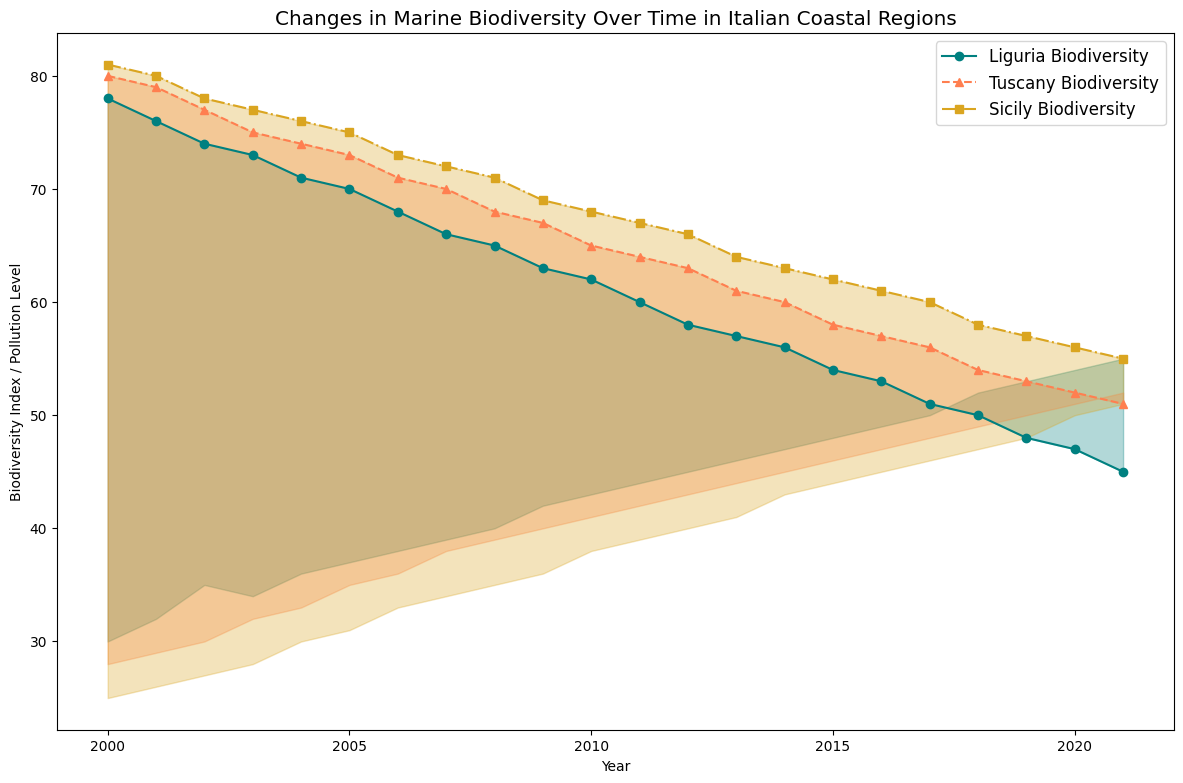In which region did the Biodiversity Index show the greatest decline from 2000 to 2021? Looking at the three regions (Liguria, Tuscany, and Sicily) on the plot, Liguria's Biodiversity Index dropped from around 78 to 45, Tuscany's from 80 to 51, and Sicily's from 81 to 55. Liguria experienced the greatest decline.
Answer: Liguria How does the pollution level change over time compare between Tuscany and Sicily from 2000 to 2021? Observing the plot, both Tuscany and Sicily show an upward trend in pollution levels from 2000 to 2021 but at different rates. Initially, Tuscany's pollution starts at 28 and ends at 52, whereas Sicily's pollution starts at 25 and ends at 51. Tuscany shows a slightly steeper increase in pollution levels over time.
Answer: Tuscany shows a slightly steeper increase Describe the visual difference in the area filled between the Biodiversity Index and Pollution Level for Liguria compared to Sicily. Liguria's area between the lines has a more pronounced downward slope towards the right, showing both rising pollution and a more steeply declining Biodiversity Index. Sicily shows a similar trend but to a lesser extent, with a smaller area between the lines suggesting a slower impact on biodiversity.
Answer: Liguria has a more pronounced decline Which region had the highest level of biodiversity in the year 2000 according to the plot? Looking at the starting points of the Biodiversity Index lines for the year 2000, Sicily starts at 81, Tuscany at 80, and Liguria at 78. Thus, Sicily had the highest biodiversity in 2000.
Answer: Sicily From which year does Liguria's Biodiversity Index drop below 60? Referring to the plot, Liguria's Biodiversity Index drops below 60 right after the year 2011, where it is shown at 60. So, it continues below 60 from 2012 onwards.
Answer: 2012 Between Tuscany and Liguria, which region had a higher pollution level in 2010? Examining the pollution levels plotted, Tuscany has a pollution level of 41 in 2010 while Liguria's pollution level is 43 in the same year. Therefore, Liguria had a higher pollution level in 2010.
Answer: Liguria By observing the area between the Biodiversity Index and Pollution Levels, which region appears to suffer the least impact of pollution on biodiversity over the years? The region with the smallest area between the Biodiversity Index and Pollution Levels would indicate a less severe impact. Sicily's area between the lines is narrower compared to Liguria and Tuscany, suggesting Sicily suffered the least relative impact over the years.
Answer: Sicily Approximately when did Tuscany's Biodiversity Index first fall below 70? Observing the line for Tuscany, the Biodiversity Index crosses below 70 around the year 2006.
Answer: Around 2006 What is the difference in Liguria's Biodiversity Index between 2005 and 2010? According to the plot, Liguria's Biodiversity Index in 2005 is 70 and in 2010 is 62. Subtracting these values gives 70 - 62 = 8.
Answer: 8 If the trend continues, in which year is Liguria's Biodiversity Index projected to drop below 40? Based on the plot, Liguria's Biodiversity Index shows a nearly consistent rate of decline. If the index was 45 in 2021, projecting with a similar decline, it may drop below 40 around 2025.
Answer: Around 2025 